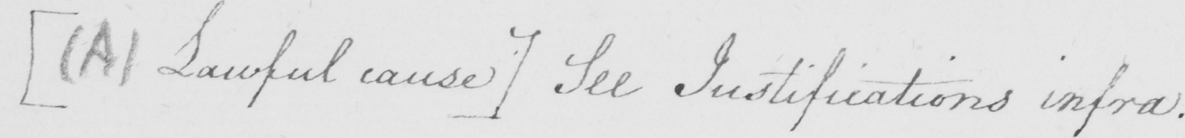Please transcribe the handwritten text in this image. [  ( A )  Lawful cause ]  See Justifications infra . 